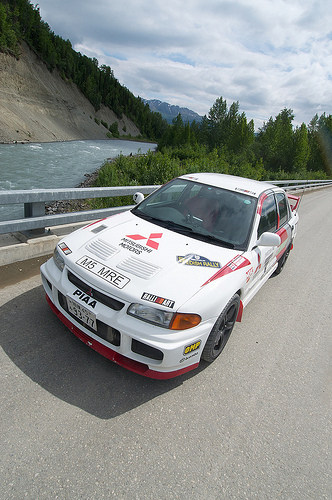<image>
Can you confirm if the bridge is under the water? No. The bridge is not positioned under the water. The vertical relationship between these objects is different. Is the mountain behind the car? Yes. From this viewpoint, the mountain is positioned behind the car, with the car partially or fully occluding the mountain. Is there a car to the right of the water? Yes. From this viewpoint, the car is positioned to the right side relative to the water. 